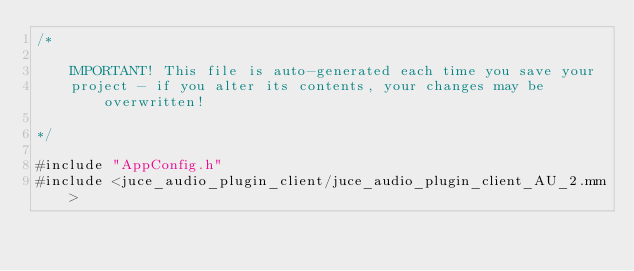Convert code to text. <code><loc_0><loc_0><loc_500><loc_500><_ObjectiveC_>/*

    IMPORTANT! This file is auto-generated each time you save your
    project - if you alter its contents, your changes may be overwritten!

*/

#include "AppConfig.h"
#include <juce_audio_plugin_client/juce_audio_plugin_client_AU_2.mm>
</code> 